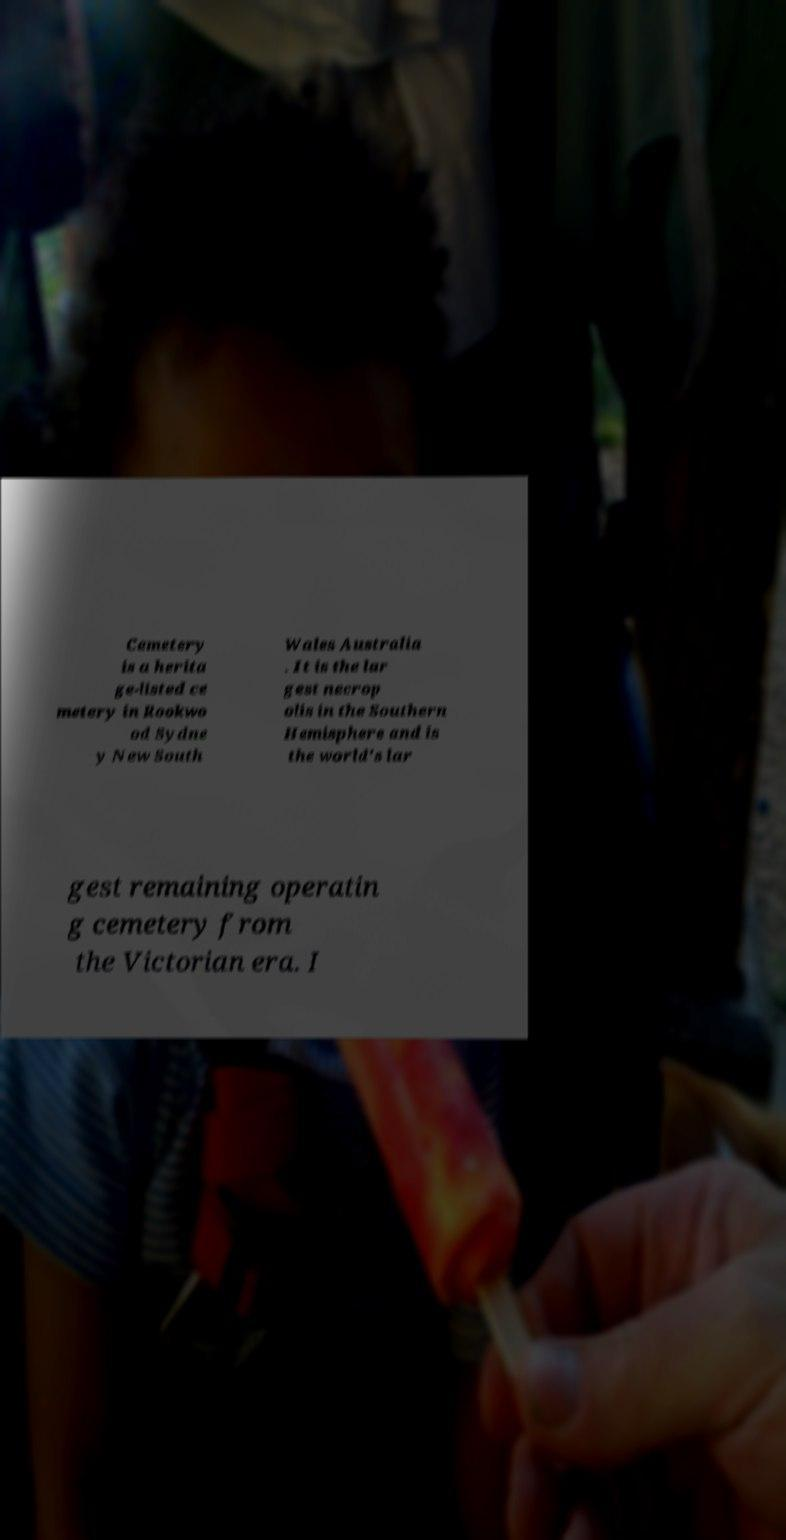Can you read and provide the text displayed in the image?This photo seems to have some interesting text. Can you extract and type it out for me? Cemetery is a herita ge-listed ce metery in Rookwo od Sydne y New South Wales Australia . It is the lar gest necrop olis in the Southern Hemisphere and is the world's lar gest remaining operatin g cemetery from the Victorian era. I 